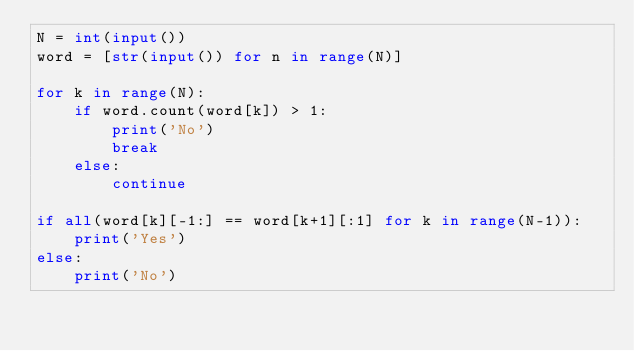<code> <loc_0><loc_0><loc_500><loc_500><_Python_>N = int(input())
word = [str(input()) for n in range(N)]

for k in range(N):
    if word.count(word[k]) > 1:
        print('No')
        break
    else:
        continue

if all(word[k][-1:] == word[k+1][:1] for k in range(N-1)):
    print('Yes')
else:
    print('No')</code> 